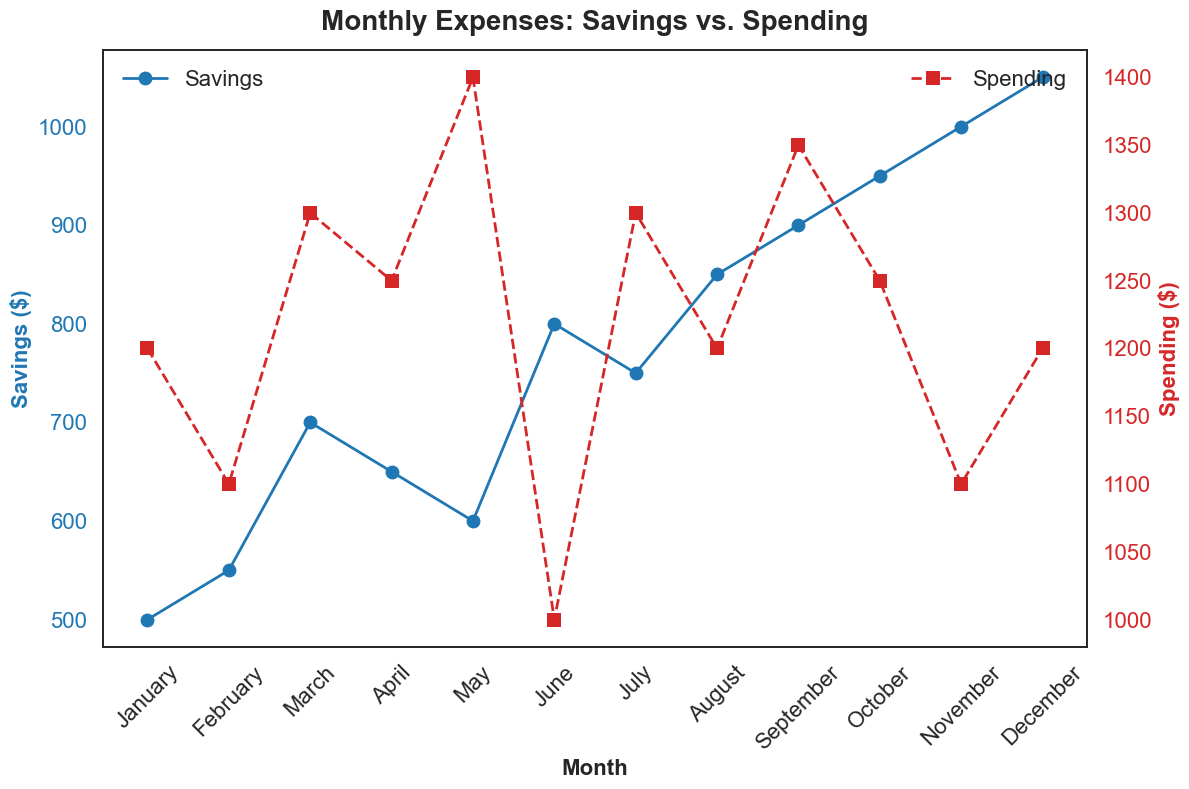What trend do the savings exhibit over the months? To determine the trend of the savings, observe the line representing the savings data (blue color) from January to December. It shows an increasing trend as the savings values constantly rise each month.
Answer: Increasing Which month has the highest spending? Look for the peak value on the red line (spending) on the secondary y-axis. The month associated with the highest y-axis value for spending is May.
Answer: May In which month is the gap between spending and savings the smallest? Calculate the gap for each month by finding the absolute difference between savings and spending. The smallest gap appears in June, where spending is $1000 and savings are $800.
Answer: June What is the difference between the savings and spending in November? Identify the values for November: savings are $1000 and spending are $1100. The difference is $1100 - $1000 = $100.
Answer: $100 Is there any month where the savings surpass the spending? Compare each month's values for savings (blue) and spending (red). No month shows savings surpassing spending as per the given data.
Answer: No During which month do the savings show the most significant increase from the previous month? Subtract the savings value of each month from its previous month to identify the most significant gain. The biggest increase occurs from August to September, rising from $850 to $900, a $100 increase.
Answer: September How much more did Matanat save in December compared to January? Identify the values: savings in December are $1050 and savings in January are $500. The increase is $1050 - $500 = $550.
Answer: $550 Compare the trends of savings vs. spending throughout the year. Which one fluctuates more? Examine both lines on the chart. The savings show a steady upward trend, whereas spending fluctuates more with noticeable peaks and troughs.
Answer: Spending In which months do spending and savings have the same trend direction (both increasing or both decreasing)? Compare the direction of the lines in consecutive months. Both spending and savings increase simultaneously during February and March, and November and December.
Answer: February-March, November-December 